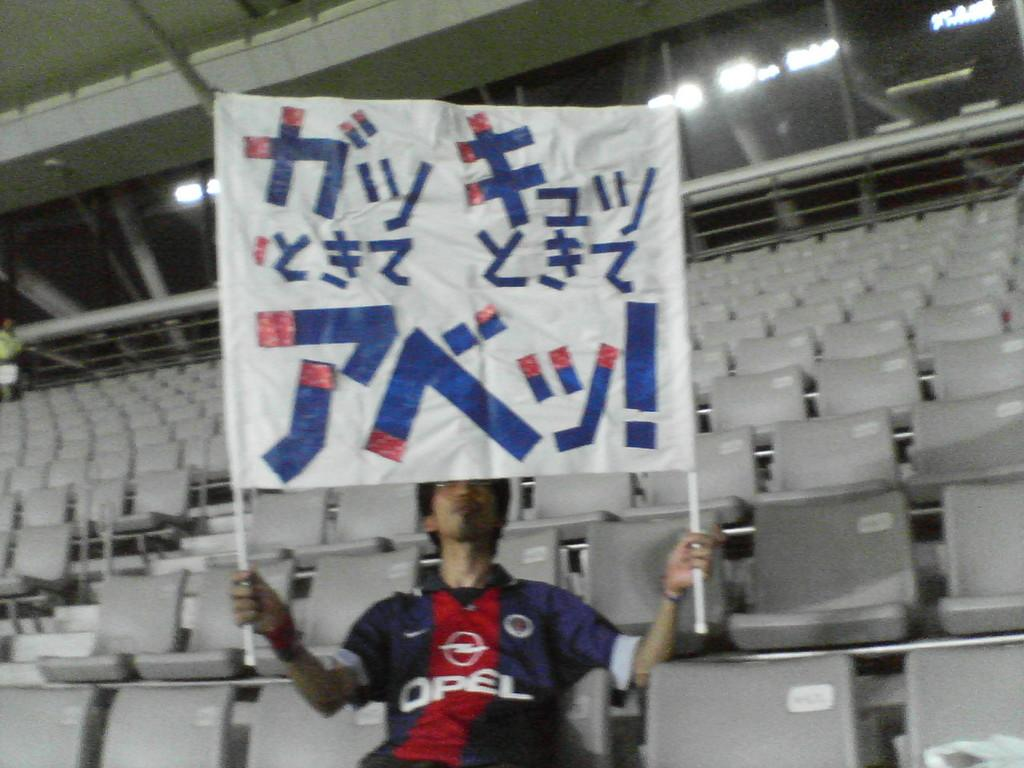<image>
Describe the image concisely. A fan wearing a blue and red Opel shirt holds a banner. 